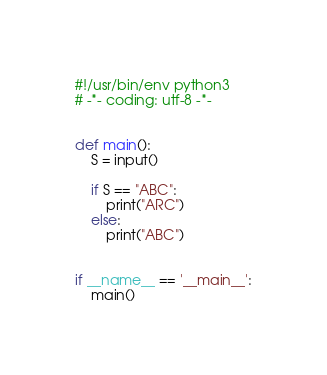Convert code to text. <code><loc_0><loc_0><loc_500><loc_500><_Python_>#!/usr/bin/env python3
# -*- coding: utf-8 -*-


def main():
    S = input()

    if S == "ABC":
        print("ARC")
    else:
        print("ABC")


if __name__ == '__main__':
    main()</code> 